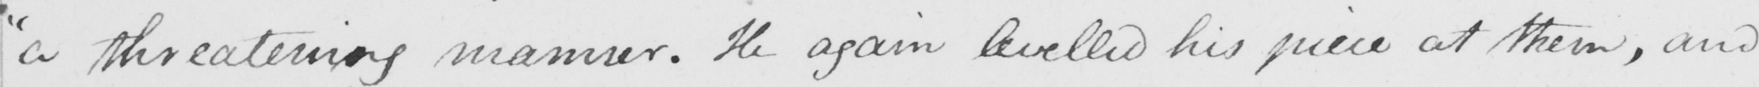Please transcribe the handwritten text in this image. " a threatening manner . He again levelled his piece at them , and 